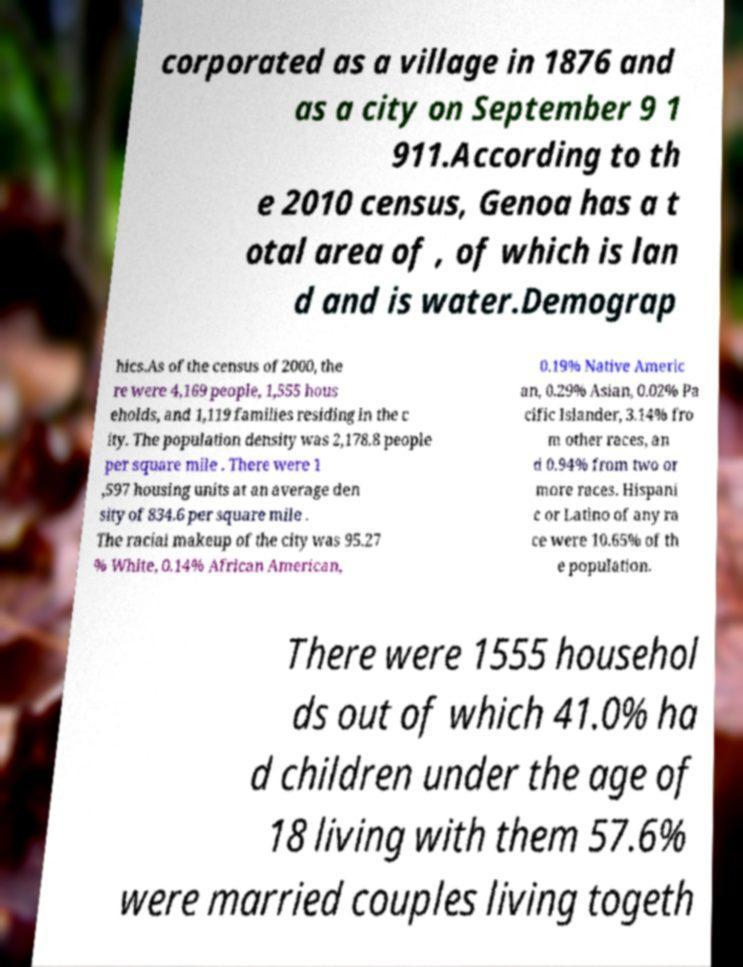Please read and relay the text visible in this image. What does it say? corporated as a village in 1876 and as a city on September 9 1 911.According to th e 2010 census, Genoa has a t otal area of , of which is lan d and is water.Demograp hics.As of the census of 2000, the re were 4,169 people, 1,555 hous eholds, and 1,119 families residing in the c ity. The population density was 2,178.8 people per square mile . There were 1 ,597 housing units at an average den sity of 834.6 per square mile . The racial makeup of the city was 95.27 % White, 0.14% African American, 0.19% Native Americ an, 0.29% Asian, 0.02% Pa cific Islander, 3.14% fro m other races, an d 0.94% from two or more races. Hispani c or Latino of any ra ce were 10.65% of th e population. There were 1555 househol ds out of which 41.0% ha d children under the age of 18 living with them 57.6% were married couples living togeth 